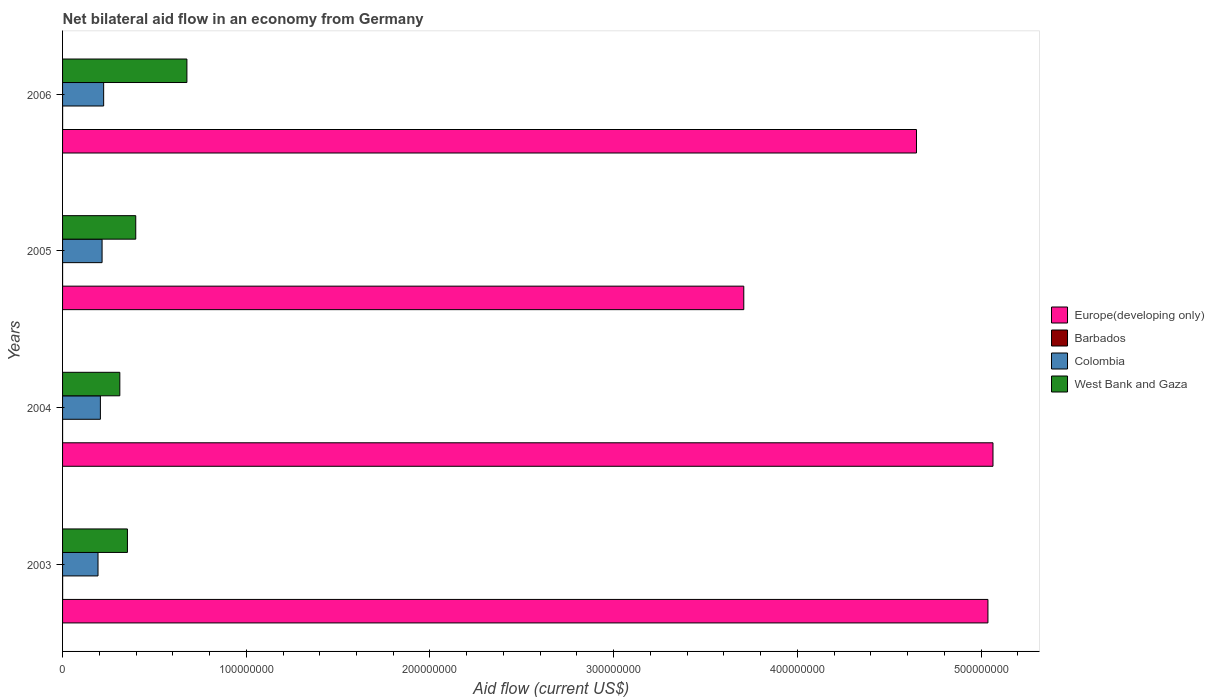How many groups of bars are there?
Provide a short and direct response. 4. Are the number of bars per tick equal to the number of legend labels?
Your response must be concise. Yes. How many bars are there on the 2nd tick from the top?
Make the answer very short. 4. What is the label of the 1st group of bars from the top?
Your answer should be very brief. 2006. What is the net bilateral aid flow in West Bank and Gaza in 2006?
Your response must be concise. 6.77e+07. Across all years, what is the maximum net bilateral aid flow in West Bank and Gaza?
Provide a short and direct response. 6.77e+07. What is the difference between the net bilateral aid flow in Colombia in 2004 and that in 2006?
Provide a short and direct response. -1.78e+06. What is the difference between the net bilateral aid flow in West Bank and Gaza in 2006 and the net bilateral aid flow in Barbados in 2003?
Give a very brief answer. 6.76e+07. What is the average net bilateral aid flow in Barbados per year?
Give a very brief answer. 1.75e+04. In the year 2006, what is the difference between the net bilateral aid flow in Europe(developing only) and net bilateral aid flow in Barbados?
Provide a short and direct response. 4.65e+08. In how many years, is the net bilateral aid flow in Europe(developing only) greater than 500000000 US$?
Offer a terse response. 2. What is the ratio of the net bilateral aid flow in Colombia in 2003 to that in 2004?
Provide a succinct answer. 0.94. What is the difference between the highest and the second highest net bilateral aid flow in Colombia?
Your answer should be very brief. 8.60e+05. What is the difference between the highest and the lowest net bilateral aid flow in Barbados?
Provide a succinct answer. 2.00e+04. Is it the case that in every year, the sum of the net bilateral aid flow in Colombia and net bilateral aid flow in Europe(developing only) is greater than the sum of net bilateral aid flow in Barbados and net bilateral aid flow in West Bank and Gaza?
Offer a very short reply. Yes. What does the 1st bar from the top in 2004 represents?
Your answer should be very brief. West Bank and Gaza. What does the 2nd bar from the bottom in 2003 represents?
Give a very brief answer. Barbados. Is it the case that in every year, the sum of the net bilateral aid flow in West Bank and Gaza and net bilateral aid flow in Europe(developing only) is greater than the net bilateral aid flow in Barbados?
Keep it short and to the point. Yes. How many bars are there?
Offer a terse response. 16. Are all the bars in the graph horizontal?
Provide a short and direct response. Yes. Does the graph contain any zero values?
Provide a succinct answer. No. Does the graph contain grids?
Keep it short and to the point. No. Where does the legend appear in the graph?
Provide a short and direct response. Center right. How many legend labels are there?
Give a very brief answer. 4. What is the title of the graph?
Ensure brevity in your answer.  Net bilateral aid flow in an economy from Germany. What is the label or title of the X-axis?
Keep it short and to the point. Aid flow (current US$). What is the label or title of the Y-axis?
Keep it short and to the point. Years. What is the Aid flow (current US$) in Europe(developing only) in 2003?
Make the answer very short. 5.04e+08. What is the Aid flow (current US$) in Barbados in 2003?
Offer a very short reply. 3.00e+04. What is the Aid flow (current US$) in Colombia in 2003?
Offer a terse response. 1.93e+07. What is the Aid flow (current US$) in West Bank and Gaza in 2003?
Your answer should be compact. 3.53e+07. What is the Aid flow (current US$) in Europe(developing only) in 2004?
Keep it short and to the point. 5.06e+08. What is the Aid flow (current US$) in Colombia in 2004?
Keep it short and to the point. 2.06e+07. What is the Aid flow (current US$) in West Bank and Gaza in 2004?
Keep it short and to the point. 3.12e+07. What is the Aid flow (current US$) of Europe(developing only) in 2005?
Your answer should be very brief. 3.71e+08. What is the Aid flow (current US$) of Barbados in 2005?
Give a very brief answer. 10000. What is the Aid flow (current US$) of Colombia in 2005?
Provide a succinct answer. 2.15e+07. What is the Aid flow (current US$) of West Bank and Gaza in 2005?
Provide a succinct answer. 3.98e+07. What is the Aid flow (current US$) in Europe(developing only) in 2006?
Give a very brief answer. 4.65e+08. What is the Aid flow (current US$) of Barbados in 2006?
Your answer should be very brief. 2.00e+04. What is the Aid flow (current US$) in Colombia in 2006?
Keep it short and to the point. 2.24e+07. What is the Aid flow (current US$) of West Bank and Gaza in 2006?
Offer a very short reply. 6.77e+07. Across all years, what is the maximum Aid flow (current US$) in Europe(developing only)?
Offer a very short reply. 5.06e+08. Across all years, what is the maximum Aid flow (current US$) in Colombia?
Your answer should be very brief. 2.24e+07. Across all years, what is the maximum Aid flow (current US$) in West Bank and Gaza?
Make the answer very short. 6.77e+07. Across all years, what is the minimum Aid flow (current US$) in Europe(developing only)?
Your answer should be very brief. 3.71e+08. Across all years, what is the minimum Aid flow (current US$) in Barbados?
Ensure brevity in your answer.  10000. Across all years, what is the minimum Aid flow (current US$) in Colombia?
Offer a very short reply. 1.93e+07. Across all years, what is the minimum Aid flow (current US$) of West Bank and Gaza?
Ensure brevity in your answer.  3.12e+07. What is the total Aid flow (current US$) in Europe(developing only) in the graph?
Your answer should be compact. 1.85e+09. What is the total Aid flow (current US$) in Barbados in the graph?
Offer a terse response. 7.00e+04. What is the total Aid flow (current US$) of Colombia in the graph?
Keep it short and to the point. 8.38e+07. What is the total Aid flow (current US$) in West Bank and Gaza in the graph?
Your response must be concise. 1.74e+08. What is the difference between the Aid flow (current US$) in Europe(developing only) in 2003 and that in 2004?
Give a very brief answer. -2.75e+06. What is the difference between the Aid flow (current US$) of Barbados in 2003 and that in 2004?
Offer a terse response. 2.00e+04. What is the difference between the Aid flow (current US$) of Colombia in 2003 and that in 2004?
Offer a very short reply. -1.29e+06. What is the difference between the Aid flow (current US$) in West Bank and Gaza in 2003 and that in 2004?
Make the answer very short. 4.14e+06. What is the difference between the Aid flow (current US$) of Europe(developing only) in 2003 and that in 2005?
Your answer should be compact. 1.33e+08. What is the difference between the Aid flow (current US$) of Colombia in 2003 and that in 2005?
Make the answer very short. -2.21e+06. What is the difference between the Aid flow (current US$) in West Bank and Gaza in 2003 and that in 2005?
Provide a short and direct response. -4.53e+06. What is the difference between the Aid flow (current US$) in Europe(developing only) in 2003 and that in 2006?
Make the answer very short. 3.89e+07. What is the difference between the Aid flow (current US$) in Barbados in 2003 and that in 2006?
Provide a short and direct response. 10000. What is the difference between the Aid flow (current US$) of Colombia in 2003 and that in 2006?
Your answer should be compact. -3.07e+06. What is the difference between the Aid flow (current US$) in West Bank and Gaza in 2003 and that in 2006?
Keep it short and to the point. -3.24e+07. What is the difference between the Aid flow (current US$) in Europe(developing only) in 2004 and that in 2005?
Give a very brief answer. 1.36e+08. What is the difference between the Aid flow (current US$) in Barbados in 2004 and that in 2005?
Your answer should be very brief. 0. What is the difference between the Aid flow (current US$) in Colombia in 2004 and that in 2005?
Ensure brevity in your answer.  -9.20e+05. What is the difference between the Aid flow (current US$) of West Bank and Gaza in 2004 and that in 2005?
Provide a short and direct response. -8.67e+06. What is the difference between the Aid flow (current US$) of Europe(developing only) in 2004 and that in 2006?
Offer a very short reply. 4.16e+07. What is the difference between the Aid flow (current US$) of Colombia in 2004 and that in 2006?
Your response must be concise. -1.78e+06. What is the difference between the Aid flow (current US$) of West Bank and Gaza in 2004 and that in 2006?
Provide a short and direct response. -3.65e+07. What is the difference between the Aid flow (current US$) of Europe(developing only) in 2005 and that in 2006?
Provide a short and direct response. -9.40e+07. What is the difference between the Aid flow (current US$) of Colombia in 2005 and that in 2006?
Keep it short and to the point. -8.60e+05. What is the difference between the Aid flow (current US$) in West Bank and Gaza in 2005 and that in 2006?
Provide a succinct answer. -2.78e+07. What is the difference between the Aid flow (current US$) in Europe(developing only) in 2003 and the Aid flow (current US$) in Barbados in 2004?
Offer a very short reply. 5.04e+08. What is the difference between the Aid flow (current US$) of Europe(developing only) in 2003 and the Aid flow (current US$) of Colombia in 2004?
Provide a succinct answer. 4.83e+08. What is the difference between the Aid flow (current US$) in Europe(developing only) in 2003 and the Aid flow (current US$) in West Bank and Gaza in 2004?
Give a very brief answer. 4.73e+08. What is the difference between the Aid flow (current US$) in Barbados in 2003 and the Aid flow (current US$) in Colombia in 2004?
Make the answer very short. -2.06e+07. What is the difference between the Aid flow (current US$) of Barbados in 2003 and the Aid flow (current US$) of West Bank and Gaza in 2004?
Your response must be concise. -3.11e+07. What is the difference between the Aid flow (current US$) in Colombia in 2003 and the Aid flow (current US$) in West Bank and Gaza in 2004?
Provide a succinct answer. -1.19e+07. What is the difference between the Aid flow (current US$) of Europe(developing only) in 2003 and the Aid flow (current US$) of Barbados in 2005?
Offer a very short reply. 5.04e+08. What is the difference between the Aid flow (current US$) in Europe(developing only) in 2003 and the Aid flow (current US$) in Colombia in 2005?
Keep it short and to the point. 4.82e+08. What is the difference between the Aid flow (current US$) of Europe(developing only) in 2003 and the Aid flow (current US$) of West Bank and Gaza in 2005?
Your answer should be compact. 4.64e+08. What is the difference between the Aid flow (current US$) of Barbados in 2003 and the Aid flow (current US$) of Colombia in 2005?
Ensure brevity in your answer.  -2.15e+07. What is the difference between the Aid flow (current US$) in Barbados in 2003 and the Aid flow (current US$) in West Bank and Gaza in 2005?
Your response must be concise. -3.98e+07. What is the difference between the Aid flow (current US$) of Colombia in 2003 and the Aid flow (current US$) of West Bank and Gaza in 2005?
Your answer should be compact. -2.05e+07. What is the difference between the Aid flow (current US$) in Europe(developing only) in 2003 and the Aid flow (current US$) in Barbados in 2006?
Your response must be concise. 5.04e+08. What is the difference between the Aid flow (current US$) in Europe(developing only) in 2003 and the Aid flow (current US$) in Colombia in 2006?
Make the answer very short. 4.81e+08. What is the difference between the Aid flow (current US$) in Europe(developing only) in 2003 and the Aid flow (current US$) in West Bank and Gaza in 2006?
Your answer should be compact. 4.36e+08. What is the difference between the Aid flow (current US$) of Barbados in 2003 and the Aid flow (current US$) of Colombia in 2006?
Ensure brevity in your answer.  -2.23e+07. What is the difference between the Aid flow (current US$) of Barbados in 2003 and the Aid flow (current US$) of West Bank and Gaza in 2006?
Provide a short and direct response. -6.76e+07. What is the difference between the Aid flow (current US$) of Colombia in 2003 and the Aid flow (current US$) of West Bank and Gaza in 2006?
Keep it short and to the point. -4.84e+07. What is the difference between the Aid flow (current US$) of Europe(developing only) in 2004 and the Aid flow (current US$) of Barbados in 2005?
Your answer should be compact. 5.06e+08. What is the difference between the Aid flow (current US$) of Europe(developing only) in 2004 and the Aid flow (current US$) of Colombia in 2005?
Give a very brief answer. 4.85e+08. What is the difference between the Aid flow (current US$) in Europe(developing only) in 2004 and the Aid flow (current US$) in West Bank and Gaza in 2005?
Make the answer very short. 4.67e+08. What is the difference between the Aid flow (current US$) of Barbados in 2004 and the Aid flow (current US$) of Colombia in 2005?
Your answer should be very brief. -2.15e+07. What is the difference between the Aid flow (current US$) in Barbados in 2004 and the Aid flow (current US$) in West Bank and Gaza in 2005?
Offer a very short reply. -3.98e+07. What is the difference between the Aid flow (current US$) of Colombia in 2004 and the Aid flow (current US$) of West Bank and Gaza in 2005?
Keep it short and to the point. -1.92e+07. What is the difference between the Aid flow (current US$) in Europe(developing only) in 2004 and the Aid flow (current US$) in Barbados in 2006?
Your answer should be very brief. 5.06e+08. What is the difference between the Aid flow (current US$) of Europe(developing only) in 2004 and the Aid flow (current US$) of Colombia in 2006?
Your answer should be compact. 4.84e+08. What is the difference between the Aid flow (current US$) of Europe(developing only) in 2004 and the Aid flow (current US$) of West Bank and Gaza in 2006?
Your answer should be compact. 4.39e+08. What is the difference between the Aid flow (current US$) in Barbados in 2004 and the Aid flow (current US$) in Colombia in 2006?
Offer a terse response. -2.24e+07. What is the difference between the Aid flow (current US$) in Barbados in 2004 and the Aid flow (current US$) in West Bank and Gaza in 2006?
Your answer should be very brief. -6.77e+07. What is the difference between the Aid flow (current US$) of Colombia in 2004 and the Aid flow (current US$) of West Bank and Gaza in 2006?
Offer a terse response. -4.71e+07. What is the difference between the Aid flow (current US$) in Europe(developing only) in 2005 and the Aid flow (current US$) in Barbados in 2006?
Provide a succinct answer. 3.71e+08. What is the difference between the Aid flow (current US$) of Europe(developing only) in 2005 and the Aid flow (current US$) of Colombia in 2006?
Your response must be concise. 3.48e+08. What is the difference between the Aid flow (current US$) of Europe(developing only) in 2005 and the Aid flow (current US$) of West Bank and Gaza in 2006?
Make the answer very short. 3.03e+08. What is the difference between the Aid flow (current US$) in Barbados in 2005 and the Aid flow (current US$) in Colombia in 2006?
Your answer should be compact. -2.24e+07. What is the difference between the Aid flow (current US$) in Barbados in 2005 and the Aid flow (current US$) in West Bank and Gaza in 2006?
Make the answer very short. -6.77e+07. What is the difference between the Aid flow (current US$) of Colombia in 2005 and the Aid flow (current US$) of West Bank and Gaza in 2006?
Keep it short and to the point. -4.62e+07. What is the average Aid flow (current US$) of Europe(developing only) per year?
Provide a succinct answer. 4.61e+08. What is the average Aid flow (current US$) in Barbados per year?
Give a very brief answer. 1.75e+04. What is the average Aid flow (current US$) of Colombia per year?
Provide a succinct answer. 2.09e+07. What is the average Aid flow (current US$) of West Bank and Gaza per year?
Keep it short and to the point. 4.35e+07. In the year 2003, what is the difference between the Aid flow (current US$) in Europe(developing only) and Aid flow (current US$) in Barbados?
Keep it short and to the point. 5.04e+08. In the year 2003, what is the difference between the Aid flow (current US$) of Europe(developing only) and Aid flow (current US$) of Colombia?
Provide a short and direct response. 4.84e+08. In the year 2003, what is the difference between the Aid flow (current US$) in Europe(developing only) and Aid flow (current US$) in West Bank and Gaza?
Your response must be concise. 4.68e+08. In the year 2003, what is the difference between the Aid flow (current US$) in Barbados and Aid flow (current US$) in Colombia?
Ensure brevity in your answer.  -1.93e+07. In the year 2003, what is the difference between the Aid flow (current US$) of Barbados and Aid flow (current US$) of West Bank and Gaza?
Provide a short and direct response. -3.53e+07. In the year 2003, what is the difference between the Aid flow (current US$) of Colombia and Aid flow (current US$) of West Bank and Gaza?
Your response must be concise. -1.60e+07. In the year 2004, what is the difference between the Aid flow (current US$) in Europe(developing only) and Aid flow (current US$) in Barbados?
Keep it short and to the point. 5.06e+08. In the year 2004, what is the difference between the Aid flow (current US$) in Europe(developing only) and Aid flow (current US$) in Colombia?
Provide a succinct answer. 4.86e+08. In the year 2004, what is the difference between the Aid flow (current US$) of Europe(developing only) and Aid flow (current US$) of West Bank and Gaza?
Make the answer very short. 4.75e+08. In the year 2004, what is the difference between the Aid flow (current US$) in Barbados and Aid flow (current US$) in Colombia?
Keep it short and to the point. -2.06e+07. In the year 2004, what is the difference between the Aid flow (current US$) of Barbados and Aid flow (current US$) of West Bank and Gaza?
Your answer should be compact. -3.12e+07. In the year 2004, what is the difference between the Aid flow (current US$) in Colombia and Aid flow (current US$) in West Bank and Gaza?
Provide a short and direct response. -1.06e+07. In the year 2005, what is the difference between the Aid flow (current US$) of Europe(developing only) and Aid flow (current US$) of Barbados?
Keep it short and to the point. 3.71e+08. In the year 2005, what is the difference between the Aid flow (current US$) of Europe(developing only) and Aid flow (current US$) of Colombia?
Give a very brief answer. 3.49e+08. In the year 2005, what is the difference between the Aid flow (current US$) in Europe(developing only) and Aid flow (current US$) in West Bank and Gaza?
Ensure brevity in your answer.  3.31e+08. In the year 2005, what is the difference between the Aid flow (current US$) in Barbados and Aid flow (current US$) in Colombia?
Provide a short and direct response. -2.15e+07. In the year 2005, what is the difference between the Aid flow (current US$) in Barbados and Aid flow (current US$) in West Bank and Gaza?
Ensure brevity in your answer.  -3.98e+07. In the year 2005, what is the difference between the Aid flow (current US$) in Colombia and Aid flow (current US$) in West Bank and Gaza?
Keep it short and to the point. -1.83e+07. In the year 2006, what is the difference between the Aid flow (current US$) in Europe(developing only) and Aid flow (current US$) in Barbados?
Your answer should be very brief. 4.65e+08. In the year 2006, what is the difference between the Aid flow (current US$) of Europe(developing only) and Aid flow (current US$) of Colombia?
Make the answer very short. 4.42e+08. In the year 2006, what is the difference between the Aid flow (current US$) in Europe(developing only) and Aid flow (current US$) in West Bank and Gaza?
Your response must be concise. 3.97e+08. In the year 2006, what is the difference between the Aid flow (current US$) in Barbados and Aid flow (current US$) in Colombia?
Provide a succinct answer. -2.24e+07. In the year 2006, what is the difference between the Aid flow (current US$) in Barbados and Aid flow (current US$) in West Bank and Gaza?
Provide a short and direct response. -6.77e+07. In the year 2006, what is the difference between the Aid flow (current US$) in Colombia and Aid flow (current US$) in West Bank and Gaza?
Provide a short and direct response. -4.53e+07. What is the ratio of the Aid flow (current US$) of Europe(developing only) in 2003 to that in 2004?
Ensure brevity in your answer.  0.99. What is the ratio of the Aid flow (current US$) of Colombia in 2003 to that in 2004?
Keep it short and to the point. 0.94. What is the ratio of the Aid flow (current US$) of West Bank and Gaza in 2003 to that in 2004?
Ensure brevity in your answer.  1.13. What is the ratio of the Aid flow (current US$) of Europe(developing only) in 2003 to that in 2005?
Keep it short and to the point. 1.36. What is the ratio of the Aid flow (current US$) in Barbados in 2003 to that in 2005?
Offer a terse response. 3. What is the ratio of the Aid flow (current US$) of Colombia in 2003 to that in 2005?
Your answer should be compact. 0.9. What is the ratio of the Aid flow (current US$) of West Bank and Gaza in 2003 to that in 2005?
Offer a terse response. 0.89. What is the ratio of the Aid flow (current US$) in Europe(developing only) in 2003 to that in 2006?
Your answer should be compact. 1.08. What is the ratio of the Aid flow (current US$) of Colombia in 2003 to that in 2006?
Offer a very short reply. 0.86. What is the ratio of the Aid flow (current US$) of West Bank and Gaza in 2003 to that in 2006?
Keep it short and to the point. 0.52. What is the ratio of the Aid flow (current US$) of Europe(developing only) in 2004 to that in 2005?
Provide a short and direct response. 1.37. What is the ratio of the Aid flow (current US$) of Barbados in 2004 to that in 2005?
Keep it short and to the point. 1. What is the ratio of the Aid flow (current US$) in Colombia in 2004 to that in 2005?
Give a very brief answer. 0.96. What is the ratio of the Aid flow (current US$) of West Bank and Gaza in 2004 to that in 2005?
Your response must be concise. 0.78. What is the ratio of the Aid flow (current US$) in Europe(developing only) in 2004 to that in 2006?
Provide a succinct answer. 1.09. What is the ratio of the Aid flow (current US$) of Barbados in 2004 to that in 2006?
Give a very brief answer. 0.5. What is the ratio of the Aid flow (current US$) of Colombia in 2004 to that in 2006?
Offer a terse response. 0.92. What is the ratio of the Aid flow (current US$) in West Bank and Gaza in 2004 to that in 2006?
Your answer should be compact. 0.46. What is the ratio of the Aid flow (current US$) in Europe(developing only) in 2005 to that in 2006?
Give a very brief answer. 0.8. What is the ratio of the Aid flow (current US$) in Colombia in 2005 to that in 2006?
Offer a very short reply. 0.96. What is the ratio of the Aid flow (current US$) of West Bank and Gaza in 2005 to that in 2006?
Give a very brief answer. 0.59. What is the difference between the highest and the second highest Aid flow (current US$) in Europe(developing only)?
Provide a short and direct response. 2.75e+06. What is the difference between the highest and the second highest Aid flow (current US$) of Barbados?
Your response must be concise. 10000. What is the difference between the highest and the second highest Aid flow (current US$) in Colombia?
Your response must be concise. 8.60e+05. What is the difference between the highest and the second highest Aid flow (current US$) of West Bank and Gaza?
Make the answer very short. 2.78e+07. What is the difference between the highest and the lowest Aid flow (current US$) of Europe(developing only)?
Give a very brief answer. 1.36e+08. What is the difference between the highest and the lowest Aid flow (current US$) of Colombia?
Your answer should be compact. 3.07e+06. What is the difference between the highest and the lowest Aid flow (current US$) in West Bank and Gaza?
Make the answer very short. 3.65e+07. 